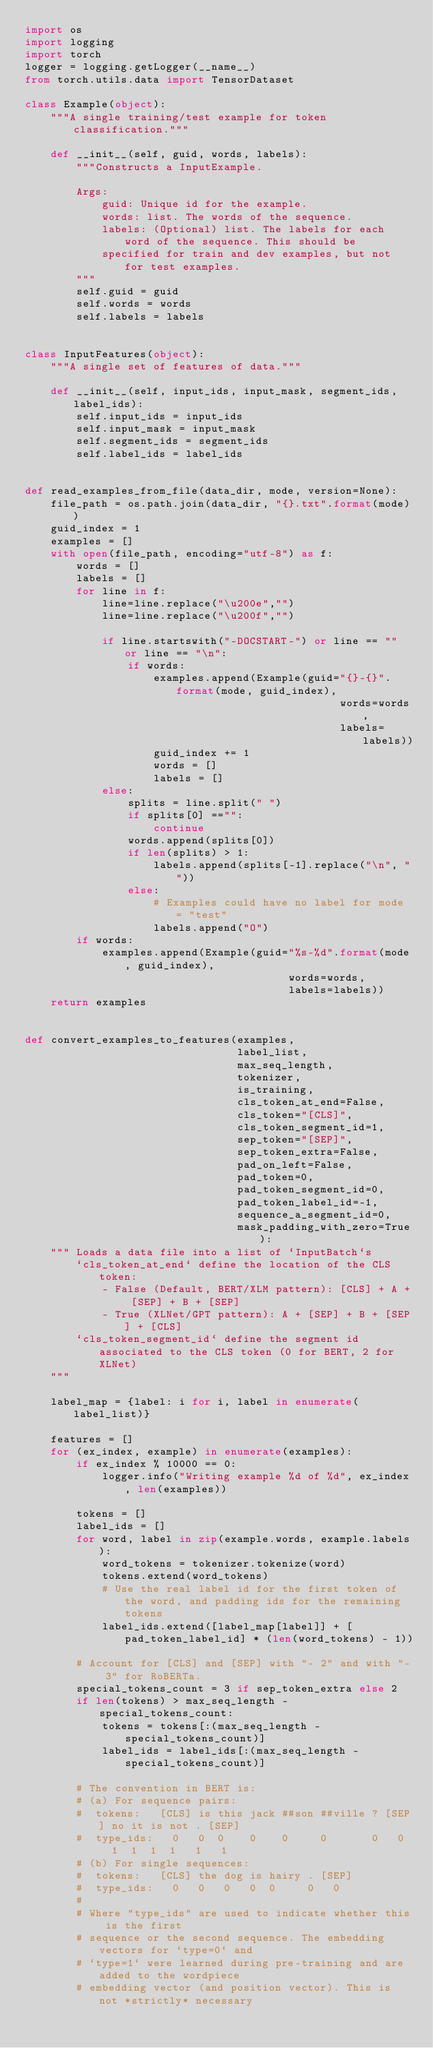Convert code to text. <code><loc_0><loc_0><loc_500><loc_500><_Python_>import os
import logging
import torch
logger = logging.getLogger(__name__)
from torch.utils.data import TensorDataset

class Example(object):
    """A single training/test example for token classification."""

    def __init__(self, guid, words, labels):
        """Constructs a InputExample.

        Args:
            guid: Unique id for the example.
            words: list. The words of the sequence.
            labels: (Optional) list. The labels for each word of the sequence. This should be
            specified for train and dev examples, but not for test examples.
        """
        self.guid = guid
        self.words = words
        self.labels = labels


class InputFeatures(object):
    """A single set of features of data."""

    def __init__(self, input_ids, input_mask, segment_ids, label_ids):
        self.input_ids = input_ids
        self.input_mask = input_mask
        self.segment_ids = segment_ids
        self.label_ids = label_ids


def read_examples_from_file(data_dir, mode, version=None):
    file_path = os.path.join(data_dir, "{}.txt".format(mode))
    guid_index = 1
    examples = []
    with open(file_path, encoding="utf-8") as f:
        words = []
        labels = []
        for line in f:
            line=line.replace("\u200e","")
            line=line.replace("\u200f","")

            if line.startswith("-DOCSTART-") or line == "" or line == "\n":
                if words:
                    examples.append(Example(guid="{}-{}".format(mode, guid_index),
                                                 words=words,
                                                 labels=labels))
                    guid_index += 1
                    words = []
                    labels = []
            else:
                splits = line.split(" ")
                if splits[0] =="":
                    continue
                words.append(splits[0])
                if len(splits) > 1:
                    labels.append(splits[-1].replace("\n", ""))
                else:
                    # Examples could have no label for mode = "test"
                    labels.append("O")
        if words:
            examples.append(Example(guid="%s-%d".format(mode, guid_index),
                                         words=words,
                                         labels=labels))
    return examples


def convert_examples_to_features(examples,
                                 label_list,
                                 max_seq_length,
                                 tokenizer,
                                 is_training,
                                 cls_token_at_end=False,
                                 cls_token="[CLS]",
                                 cls_token_segment_id=1,
                                 sep_token="[SEP]",
                                 sep_token_extra=False,
                                 pad_on_left=False,
                                 pad_token=0,
                                 pad_token_segment_id=0,
                                 pad_token_label_id=-1,
                                 sequence_a_segment_id=0,
                                 mask_padding_with_zero=True):
    """ Loads a data file into a list of `InputBatch`s
        `cls_token_at_end` define the location of the CLS token:
            - False (Default, BERT/XLM pattern): [CLS] + A + [SEP] + B + [SEP]
            - True (XLNet/GPT pattern): A + [SEP] + B + [SEP] + [CLS]
        `cls_token_segment_id` define the segment id associated to the CLS token (0 for BERT, 2 for XLNet)
    """

    label_map = {label: i for i, label in enumerate(label_list)}

    features = []
    for (ex_index, example) in enumerate(examples):
        if ex_index % 10000 == 0:
            logger.info("Writing example %d of %d", ex_index, len(examples))

        tokens = []
        label_ids = []
        for word, label in zip(example.words, example.labels):
            word_tokens = tokenizer.tokenize(word)
            tokens.extend(word_tokens)
            # Use the real label id for the first token of the word, and padding ids for the remaining tokens
            label_ids.extend([label_map[label]] + [pad_token_label_id] * (len(word_tokens) - 1))

        # Account for [CLS] and [SEP] with "- 2" and with "- 3" for RoBERTa.
        special_tokens_count = 3 if sep_token_extra else 2
        if len(tokens) > max_seq_length - special_tokens_count:
            tokens = tokens[:(max_seq_length - special_tokens_count)]
            label_ids = label_ids[:(max_seq_length - special_tokens_count)]

        # The convention in BERT is:
        # (a) For sequence pairs:
        #  tokens:   [CLS] is this jack ##son ##ville ? [SEP] no it is not . [SEP]
        #  type_ids:   0   0  0    0    0     0       0   0   1  1  1  1   1   1
        # (b) For single sequences:
        #  tokens:   [CLS] the dog is hairy . [SEP]
        #  type_ids:   0   0   0   0  0     0   0
        #
        # Where "type_ids" are used to indicate whether this is the first
        # sequence or the second sequence. The embedding vectors for `type=0` and
        # `type=1` were learned during pre-training and are added to the wordpiece
        # embedding vector (and position vector). This is not *strictly* necessary</code> 